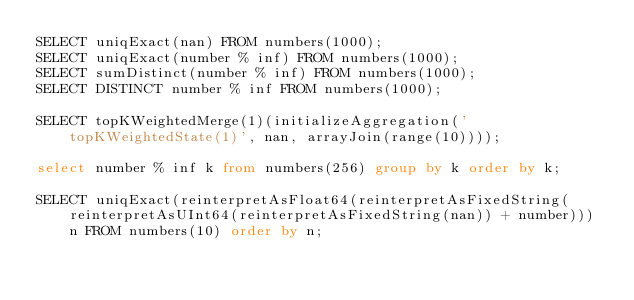<code> <loc_0><loc_0><loc_500><loc_500><_SQL_>SELECT uniqExact(nan) FROM numbers(1000);
SELECT uniqExact(number % inf) FROM numbers(1000);
SELECT sumDistinct(number % inf) FROM numbers(1000);
SELECT DISTINCT number % inf FROM numbers(1000);

SELECT topKWeightedMerge(1)(initializeAggregation('topKWeightedState(1)', nan, arrayJoin(range(10))));

select number % inf k from numbers(256) group by k order by k;

SELECT uniqExact(reinterpretAsFloat64(reinterpretAsFixedString(reinterpretAsUInt64(reinterpretAsFixedString(nan)) + number))) n FROM numbers(10) order by n;
</code> 